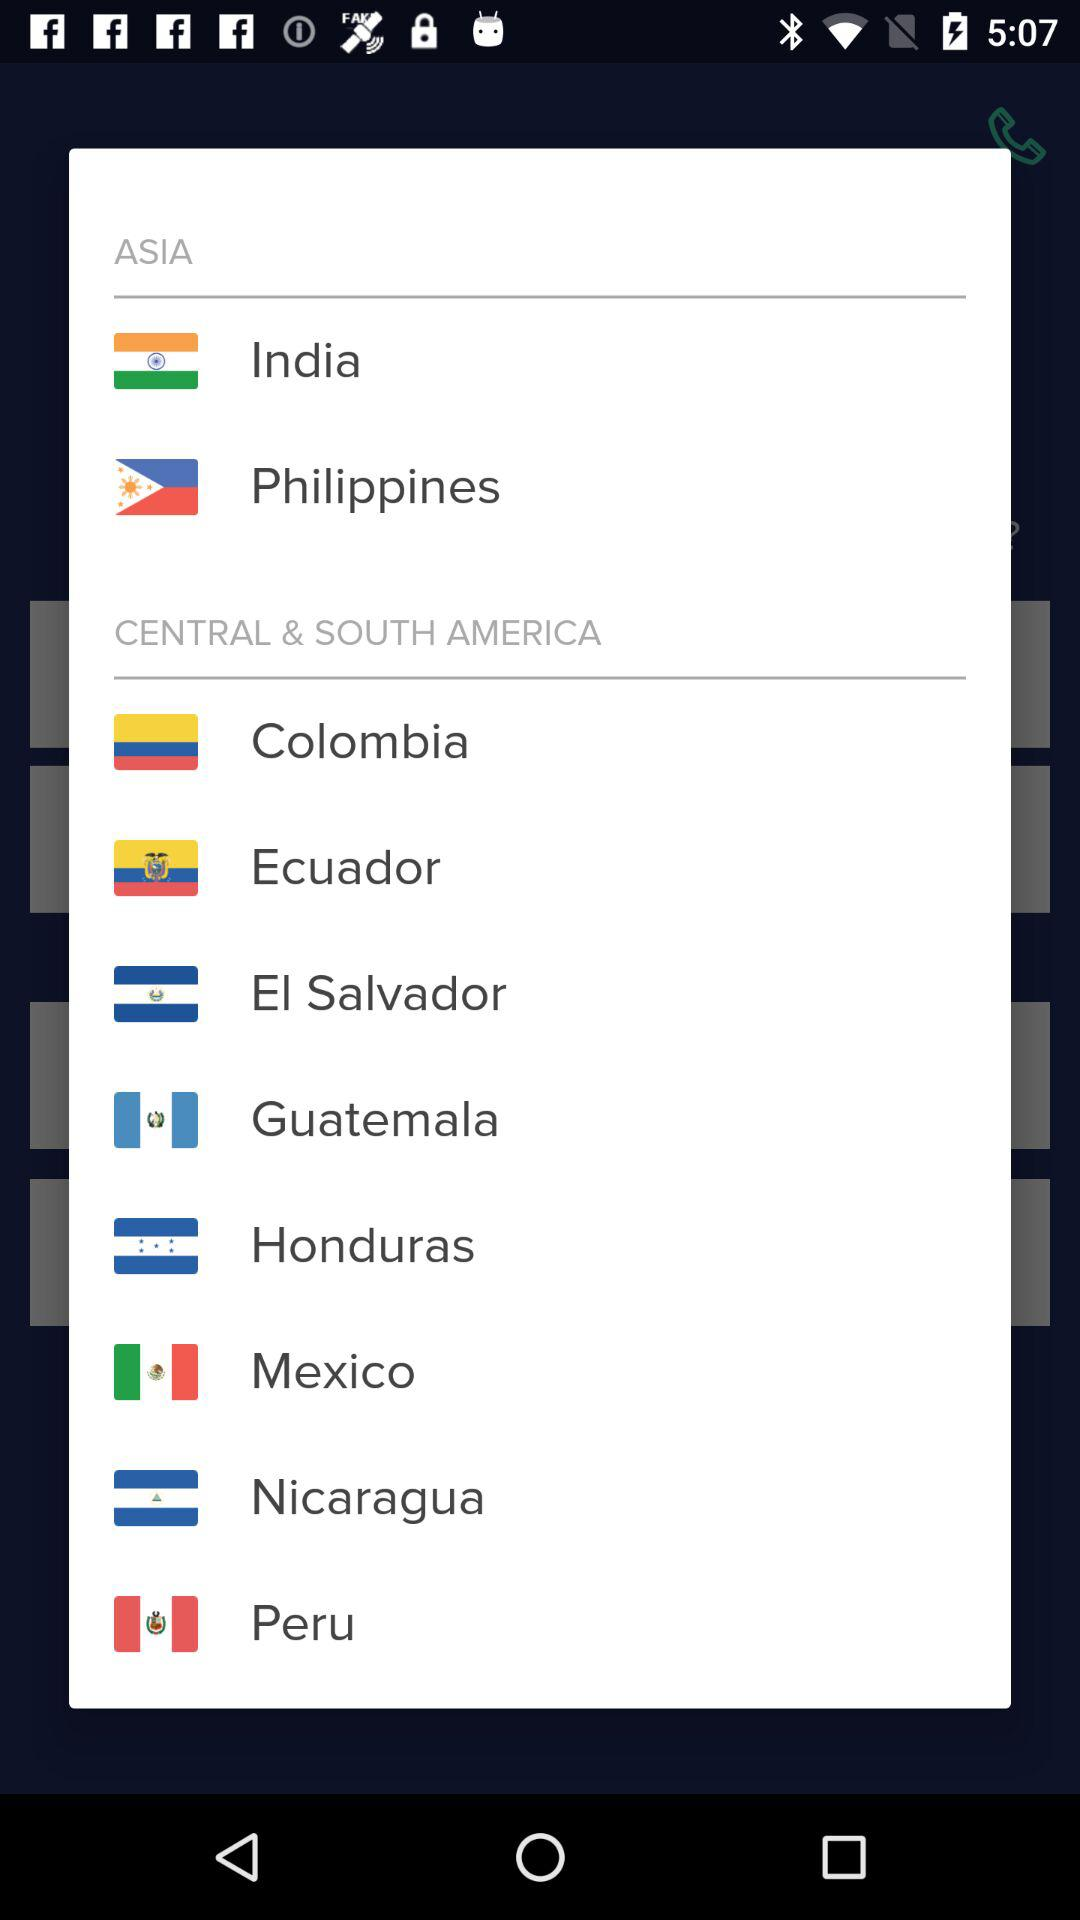How many countries are in the Central & South America section?
Answer the question using a single word or phrase. 8 